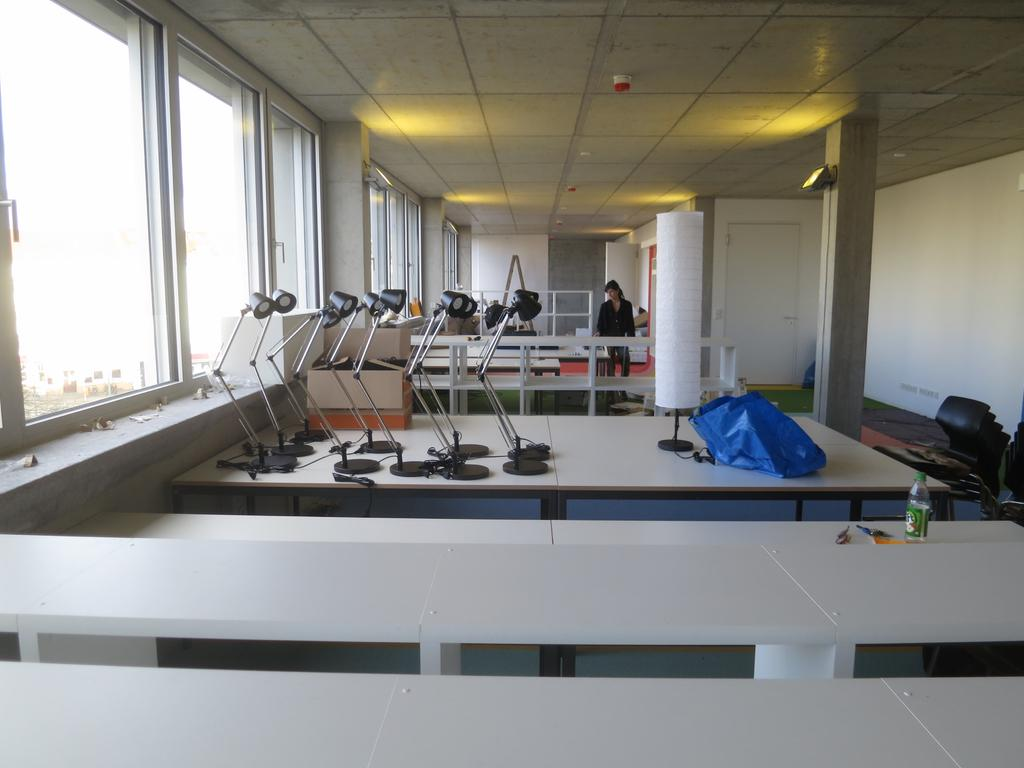What piece of furniture is present in the image? There is a table in the image. What objects are on the table? There are lamps on the table. Can you describe the person visible in the background of the image? Unfortunately, the facts provided do not give any details about the person in the background. What type of sheet is covering the cook in the image? There is no cook or sheet present in the image. Is the ghost visible in the image? There is no ghost present in the image. 